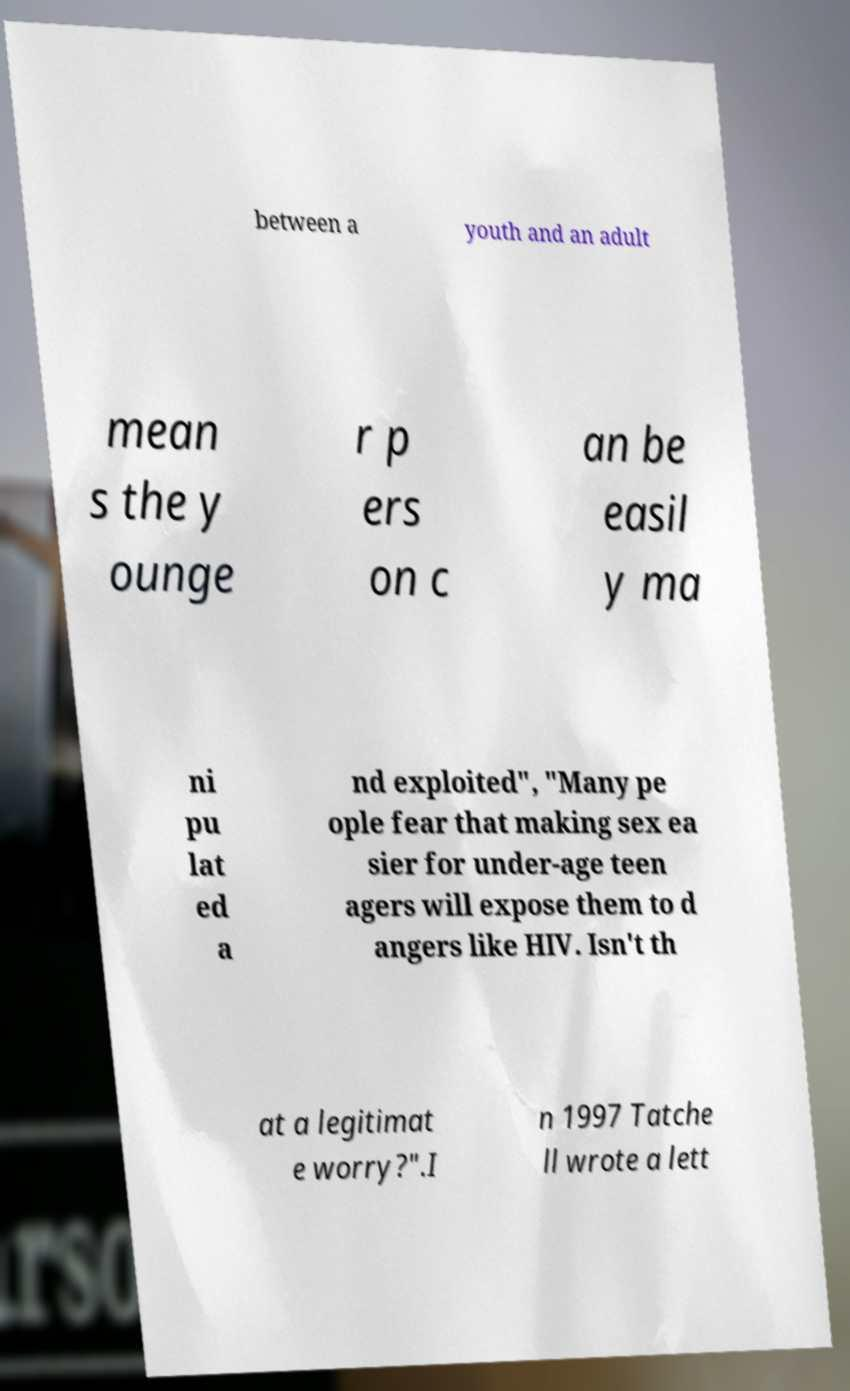Please identify and transcribe the text found in this image. between a youth and an adult mean s the y ounge r p ers on c an be easil y ma ni pu lat ed a nd exploited", "Many pe ople fear that making sex ea sier for under-age teen agers will expose them to d angers like HIV. Isn't th at a legitimat e worry?".I n 1997 Tatche ll wrote a lett 